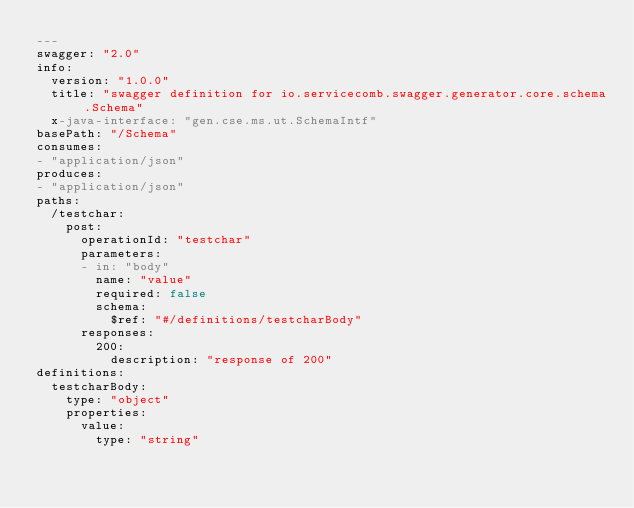Convert code to text. <code><loc_0><loc_0><loc_500><loc_500><_YAML_>---
swagger: "2.0"
info:
  version: "1.0.0"
  title: "swagger definition for io.servicecomb.swagger.generator.core.schema.Schema"
  x-java-interface: "gen.cse.ms.ut.SchemaIntf"
basePath: "/Schema"
consumes:
- "application/json"
produces:
- "application/json"
paths:
  /testchar:
    post:
      operationId: "testchar"
      parameters:
      - in: "body"
        name: "value"
        required: false
        schema:
          $ref: "#/definitions/testcharBody"
      responses:
        200:
          description: "response of 200"
definitions:
  testcharBody:
    type: "object"
    properties:
      value:
        type: "string"
</code> 